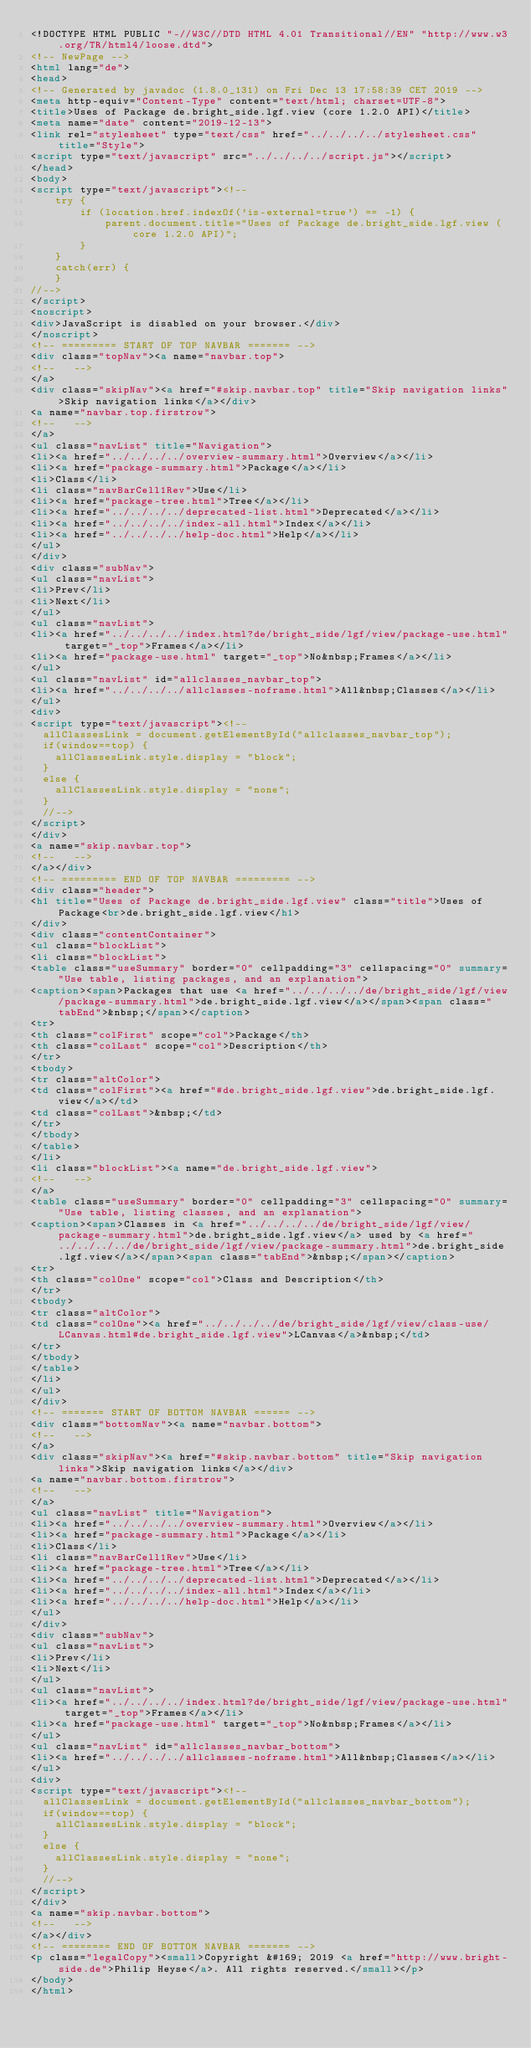Convert code to text. <code><loc_0><loc_0><loc_500><loc_500><_HTML_><!DOCTYPE HTML PUBLIC "-//W3C//DTD HTML 4.01 Transitional//EN" "http://www.w3.org/TR/html4/loose.dtd">
<!-- NewPage -->
<html lang="de">
<head>
<!-- Generated by javadoc (1.8.0_131) on Fri Dec 13 17:58:39 CET 2019 -->
<meta http-equiv="Content-Type" content="text/html; charset=UTF-8">
<title>Uses of Package de.bright_side.lgf.view (core 1.2.0 API)</title>
<meta name="date" content="2019-12-13">
<link rel="stylesheet" type="text/css" href="../../../../stylesheet.css" title="Style">
<script type="text/javascript" src="../../../../script.js"></script>
</head>
<body>
<script type="text/javascript"><!--
    try {
        if (location.href.indexOf('is-external=true') == -1) {
            parent.document.title="Uses of Package de.bright_side.lgf.view (core 1.2.0 API)";
        }
    }
    catch(err) {
    }
//-->
</script>
<noscript>
<div>JavaScript is disabled on your browser.</div>
</noscript>
<!-- ========= START OF TOP NAVBAR ======= -->
<div class="topNav"><a name="navbar.top">
<!--   -->
</a>
<div class="skipNav"><a href="#skip.navbar.top" title="Skip navigation links">Skip navigation links</a></div>
<a name="navbar.top.firstrow">
<!--   -->
</a>
<ul class="navList" title="Navigation">
<li><a href="../../../../overview-summary.html">Overview</a></li>
<li><a href="package-summary.html">Package</a></li>
<li>Class</li>
<li class="navBarCell1Rev">Use</li>
<li><a href="package-tree.html">Tree</a></li>
<li><a href="../../../../deprecated-list.html">Deprecated</a></li>
<li><a href="../../../../index-all.html">Index</a></li>
<li><a href="../../../../help-doc.html">Help</a></li>
</ul>
</div>
<div class="subNav">
<ul class="navList">
<li>Prev</li>
<li>Next</li>
</ul>
<ul class="navList">
<li><a href="../../../../index.html?de/bright_side/lgf/view/package-use.html" target="_top">Frames</a></li>
<li><a href="package-use.html" target="_top">No&nbsp;Frames</a></li>
</ul>
<ul class="navList" id="allclasses_navbar_top">
<li><a href="../../../../allclasses-noframe.html">All&nbsp;Classes</a></li>
</ul>
<div>
<script type="text/javascript"><!--
  allClassesLink = document.getElementById("allclasses_navbar_top");
  if(window==top) {
    allClassesLink.style.display = "block";
  }
  else {
    allClassesLink.style.display = "none";
  }
  //-->
</script>
</div>
<a name="skip.navbar.top">
<!--   -->
</a></div>
<!-- ========= END OF TOP NAVBAR ========= -->
<div class="header">
<h1 title="Uses of Package de.bright_side.lgf.view" class="title">Uses of Package<br>de.bright_side.lgf.view</h1>
</div>
<div class="contentContainer">
<ul class="blockList">
<li class="blockList">
<table class="useSummary" border="0" cellpadding="3" cellspacing="0" summary="Use table, listing packages, and an explanation">
<caption><span>Packages that use <a href="../../../../de/bright_side/lgf/view/package-summary.html">de.bright_side.lgf.view</a></span><span class="tabEnd">&nbsp;</span></caption>
<tr>
<th class="colFirst" scope="col">Package</th>
<th class="colLast" scope="col">Description</th>
</tr>
<tbody>
<tr class="altColor">
<td class="colFirst"><a href="#de.bright_side.lgf.view">de.bright_side.lgf.view</a></td>
<td class="colLast">&nbsp;</td>
</tr>
</tbody>
</table>
</li>
<li class="blockList"><a name="de.bright_side.lgf.view">
<!--   -->
</a>
<table class="useSummary" border="0" cellpadding="3" cellspacing="0" summary="Use table, listing classes, and an explanation">
<caption><span>Classes in <a href="../../../../de/bright_side/lgf/view/package-summary.html">de.bright_side.lgf.view</a> used by <a href="../../../../de/bright_side/lgf/view/package-summary.html">de.bright_side.lgf.view</a></span><span class="tabEnd">&nbsp;</span></caption>
<tr>
<th class="colOne" scope="col">Class and Description</th>
</tr>
<tbody>
<tr class="altColor">
<td class="colOne"><a href="../../../../de/bright_side/lgf/view/class-use/LCanvas.html#de.bright_side.lgf.view">LCanvas</a>&nbsp;</td>
</tr>
</tbody>
</table>
</li>
</ul>
</div>
<!-- ======= START OF BOTTOM NAVBAR ====== -->
<div class="bottomNav"><a name="navbar.bottom">
<!--   -->
</a>
<div class="skipNav"><a href="#skip.navbar.bottom" title="Skip navigation links">Skip navigation links</a></div>
<a name="navbar.bottom.firstrow">
<!--   -->
</a>
<ul class="navList" title="Navigation">
<li><a href="../../../../overview-summary.html">Overview</a></li>
<li><a href="package-summary.html">Package</a></li>
<li>Class</li>
<li class="navBarCell1Rev">Use</li>
<li><a href="package-tree.html">Tree</a></li>
<li><a href="../../../../deprecated-list.html">Deprecated</a></li>
<li><a href="../../../../index-all.html">Index</a></li>
<li><a href="../../../../help-doc.html">Help</a></li>
</ul>
</div>
<div class="subNav">
<ul class="navList">
<li>Prev</li>
<li>Next</li>
</ul>
<ul class="navList">
<li><a href="../../../../index.html?de/bright_side/lgf/view/package-use.html" target="_top">Frames</a></li>
<li><a href="package-use.html" target="_top">No&nbsp;Frames</a></li>
</ul>
<ul class="navList" id="allclasses_navbar_bottom">
<li><a href="../../../../allclasses-noframe.html">All&nbsp;Classes</a></li>
</ul>
<div>
<script type="text/javascript"><!--
  allClassesLink = document.getElementById("allclasses_navbar_bottom");
  if(window==top) {
    allClassesLink.style.display = "block";
  }
  else {
    allClassesLink.style.display = "none";
  }
  //-->
</script>
</div>
<a name="skip.navbar.bottom">
<!--   -->
</a></div>
<!-- ======== END OF BOTTOM NAVBAR ======= -->
<p class="legalCopy"><small>Copyright &#169; 2019 <a href="http://www.bright-side.de">Philip Heyse</a>. All rights reserved.</small></p>
</body>
</html>
</code> 